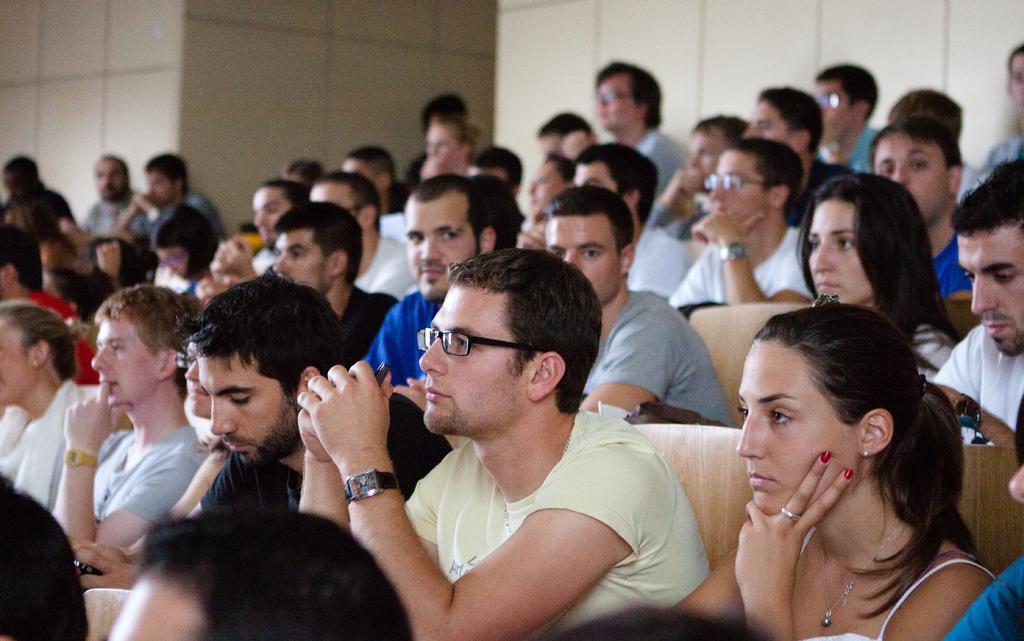Please provide a concise description of this image. In this image we can see these people are sitting on the chairs. This part of the image is slightly blurred, where we can see the wall. 